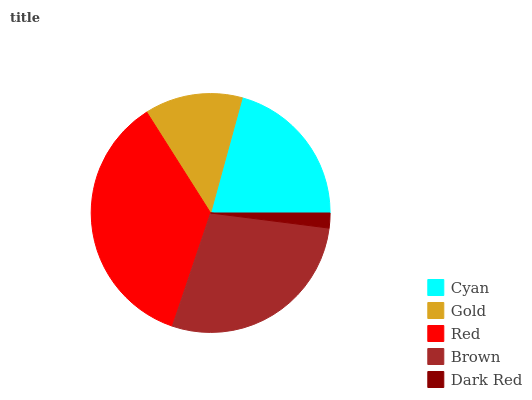Is Dark Red the minimum?
Answer yes or no. Yes. Is Red the maximum?
Answer yes or no. Yes. Is Gold the minimum?
Answer yes or no. No. Is Gold the maximum?
Answer yes or no. No. Is Cyan greater than Gold?
Answer yes or no. Yes. Is Gold less than Cyan?
Answer yes or no. Yes. Is Gold greater than Cyan?
Answer yes or no. No. Is Cyan less than Gold?
Answer yes or no. No. Is Cyan the high median?
Answer yes or no. Yes. Is Cyan the low median?
Answer yes or no. Yes. Is Brown the high median?
Answer yes or no. No. Is Gold the low median?
Answer yes or no. No. 